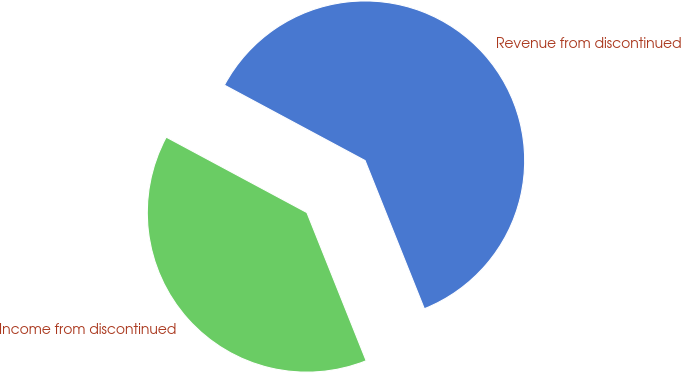<chart> <loc_0><loc_0><loc_500><loc_500><pie_chart><fcel>Revenue from discontinued<fcel>Income from discontinued<nl><fcel>61.11%<fcel>38.89%<nl></chart> 